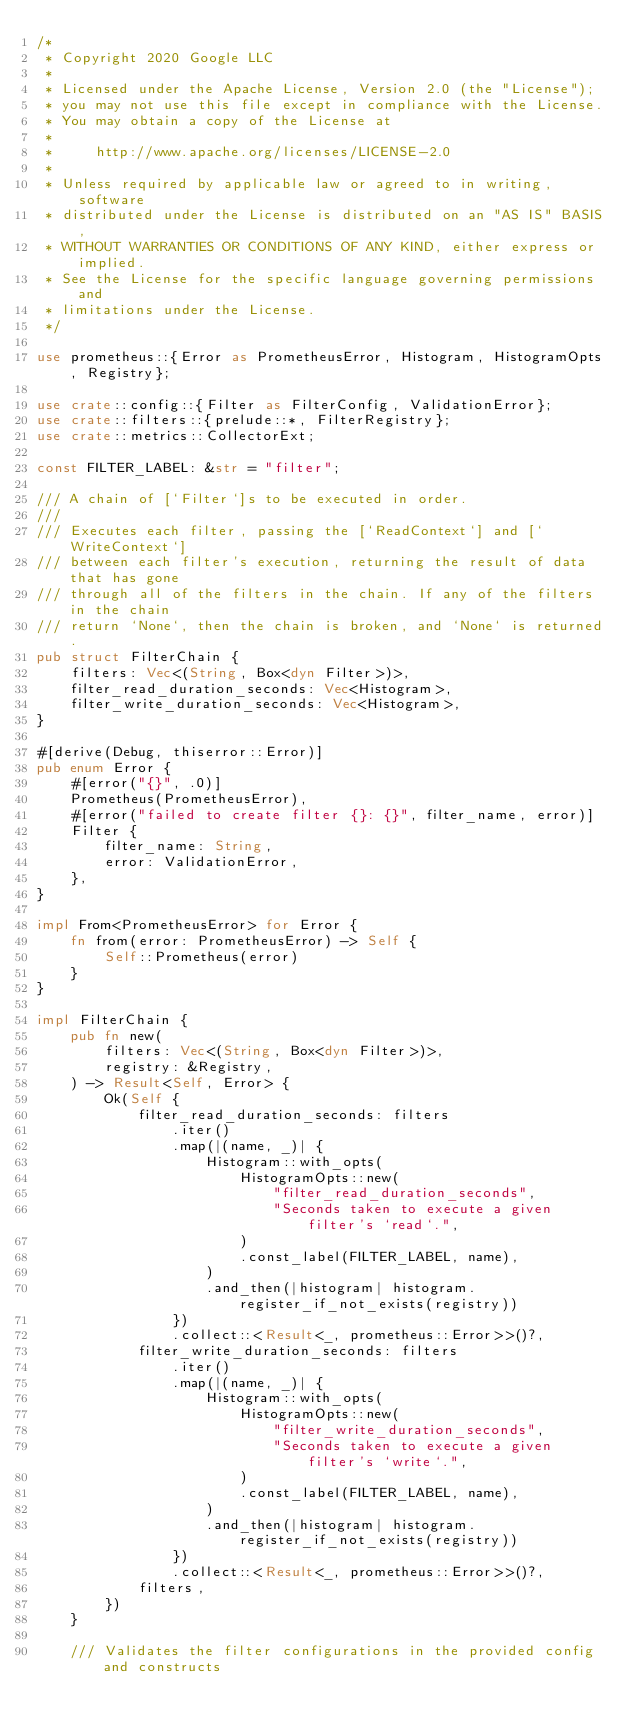Convert code to text. <code><loc_0><loc_0><loc_500><loc_500><_Rust_>/*
 * Copyright 2020 Google LLC
 *
 * Licensed under the Apache License, Version 2.0 (the "License");
 * you may not use this file except in compliance with the License.
 * You may obtain a copy of the License at
 *
 *     http://www.apache.org/licenses/LICENSE-2.0
 *
 * Unless required by applicable law or agreed to in writing, software
 * distributed under the License is distributed on an "AS IS" BASIS,
 * WITHOUT WARRANTIES OR CONDITIONS OF ANY KIND, either express or implied.
 * See the License for the specific language governing permissions and
 * limitations under the License.
 */

use prometheus::{Error as PrometheusError, Histogram, HistogramOpts, Registry};

use crate::config::{Filter as FilterConfig, ValidationError};
use crate::filters::{prelude::*, FilterRegistry};
use crate::metrics::CollectorExt;

const FILTER_LABEL: &str = "filter";

/// A chain of [`Filter`]s to be executed in order.
///
/// Executes each filter, passing the [`ReadContext`] and [`WriteContext`]
/// between each filter's execution, returning the result of data that has gone
/// through all of the filters in the chain. If any of the filters in the chain
/// return `None`, then the chain is broken, and `None` is returned.
pub struct FilterChain {
    filters: Vec<(String, Box<dyn Filter>)>,
    filter_read_duration_seconds: Vec<Histogram>,
    filter_write_duration_seconds: Vec<Histogram>,
}

#[derive(Debug, thiserror::Error)]
pub enum Error {
    #[error("{}", .0)]
    Prometheus(PrometheusError),
    #[error("failed to create filter {}: {}", filter_name, error)]
    Filter {
        filter_name: String,
        error: ValidationError,
    },
}

impl From<PrometheusError> for Error {
    fn from(error: PrometheusError) -> Self {
        Self::Prometheus(error)
    }
}

impl FilterChain {
    pub fn new(
        filters: Vec<(String, Box<dyn Filter>)>,
        registry: &Registry,
    ) -> Result<Self, Error> {
        Ok(Self {
            filter_read_duration_seconds: filters
                .iter()
                .map(|(name, _)| {
                    Histogram::with_opts(
                        HistogramOpts::new(
                            "filter_read_duration_seconds",
                            "Seconds taken to execute a given filter's `read`.",
                        )
                        .const_label(FILTER_LABEL, name),
                    )
                    .and_then(|histogram| histogram.register_if_not_exists(registry))
                })
                .collect::<Result<_, prometheus::Error>>()?,
            filter_write_duration_seconds: filters
                .iter()
                .map(|(name, _)| {
                    Histogram::with_opts(
                        HistogramOpts::new(
                            "filter_write_duration_seconds",
                            "Seconds taken to execute a given filter's `write`.",
                        )
                        .const_label(FILTER_LABEL, name),
                    )
                    .and_then(|histogram| histogram.register_if_not_exists(registry))
                })
                .collect::<Result<_, prometheus::Error>>()?,
            filters,
        })
    }

    /// Validates the filter configurations in the provided config and constructs</code> 